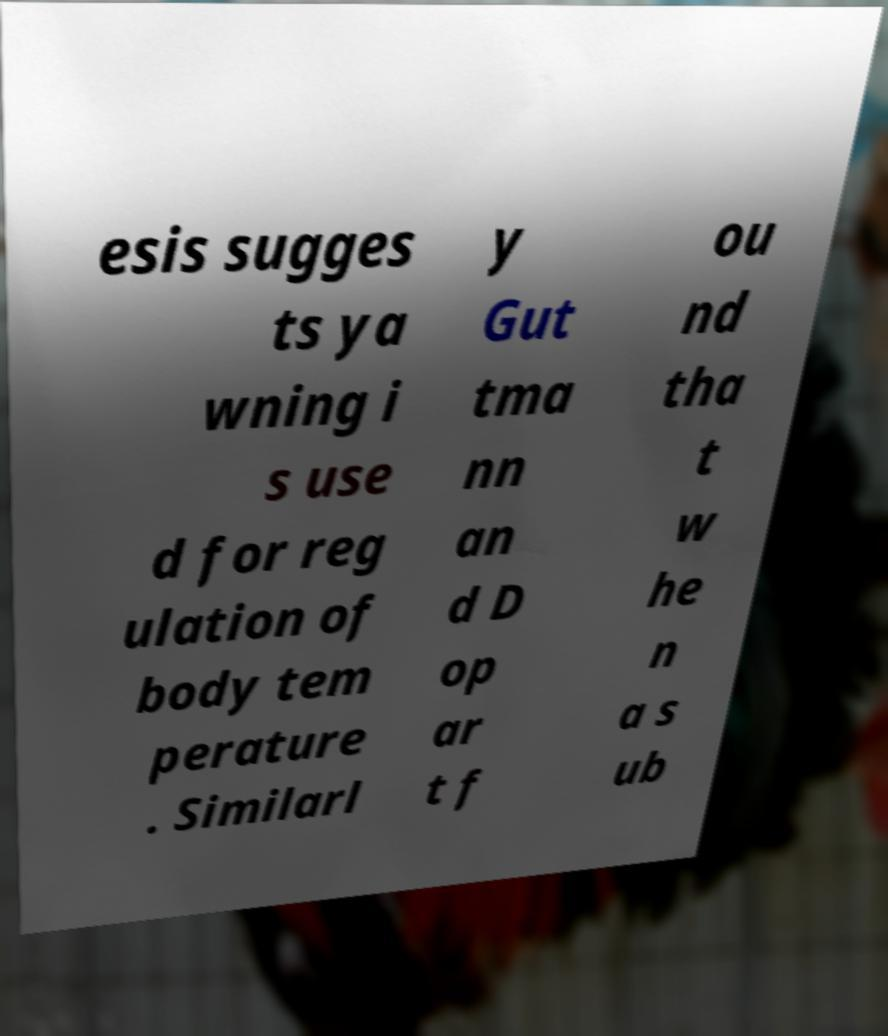Could you assist in decoding the text presented in this image and type it out clearly? esis sugges ts ya wning i s use d for reg ulation of body tem perature . Similarl y Gut tma nn an d D op ar t f ou nd tha t w he n a s ub 